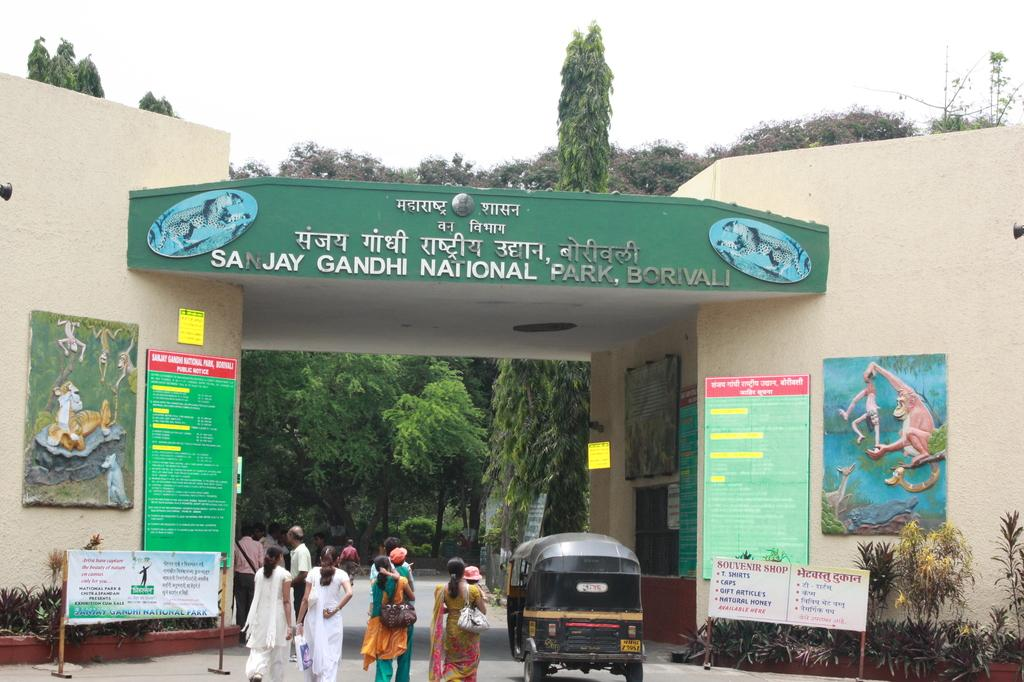What type of structure is featured in the image? There is an arch of a national park in the image. Can you describe the people in the image? There is a group of people standing in the image. What type of wildlife can be seen in the image? Birds are visible in the image. What type of vegetation is present in the image? There are plants and trees in the image. What is visible in the background of the image? The sky is visible in the background of the image. What type of banana is being used as a prop in the image? There is no banana present in the image. What side of the arch is the group of people standing on in the image? The image does not specify which side of the arch the group of people is standing on. 